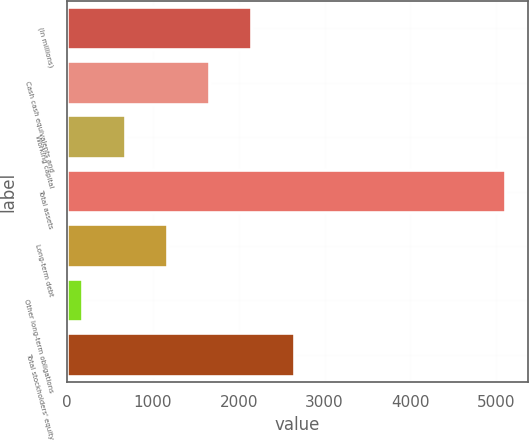Convert chart to OTSL. <chart><loc_0><loc_0><loc_500><loc_500><bar_chart><fcel>(In millions)<fcel>Cash cash equivalents and<fcel>Working capital<fcel>Total assets<fcel>Long-term debt<fcel>Other long-term obligations<fcel>Total stockholders' equity<nl><fcel>2158<fcel>1666<fcel>682<fcel>5110<fcel>1174<fcel>190<fcel>2650<nl></chart> 